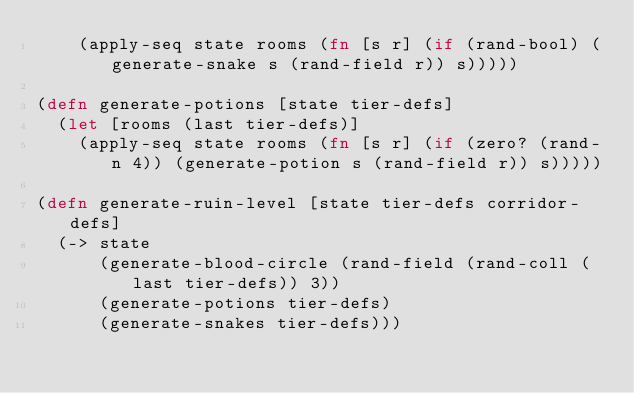<code> <loc_0><loc_0><loc_500><loc_500><_Clojure_>    (apply-seq state rooms (fn [s r] (if (rand-bool) (generate-snake s (rand-field r)) s)))))

(defn generate-potions [state tier-defs]
  (let [rooms (last tier-defs)]
    (apply-seq state rooms (fn [s r] (if (zero? (rand-n 4)) (generate-potion s (rand-field r)) s)))))

(defn generate-ruin-level [state tier-defs corridor-defs]
  (-> state
      (generate-blood-circle (rand-field (rand-coll (last tier-defs)) 3))
      (generate-potions tier-defs)
      (generate-snakes tier-defs)))</code> 